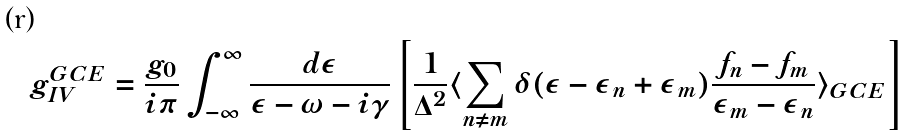<formula> <loc_0><loc_0><loc_500><loc_500>g _ { I V } ^ { G C E } = \frac { g _ { 0 } } { i \pi } \int _ { - \infty } ^ { \infty } \frac { d \epsilon } { \epsilon - \omega - i \gamma } \left [ \frac { 1 } { \Delta ^ { 2 } } \langle \sum _ { n \neq m } \delta ( \epsilon - \epsilon _ { n } + \epsilon _ { m } ) \frac { f _ { n } - f _ { m } } { \epsilon _ { m } - \epsilon _ { n } } \rangle _ { G C E } \right ]</formula> 